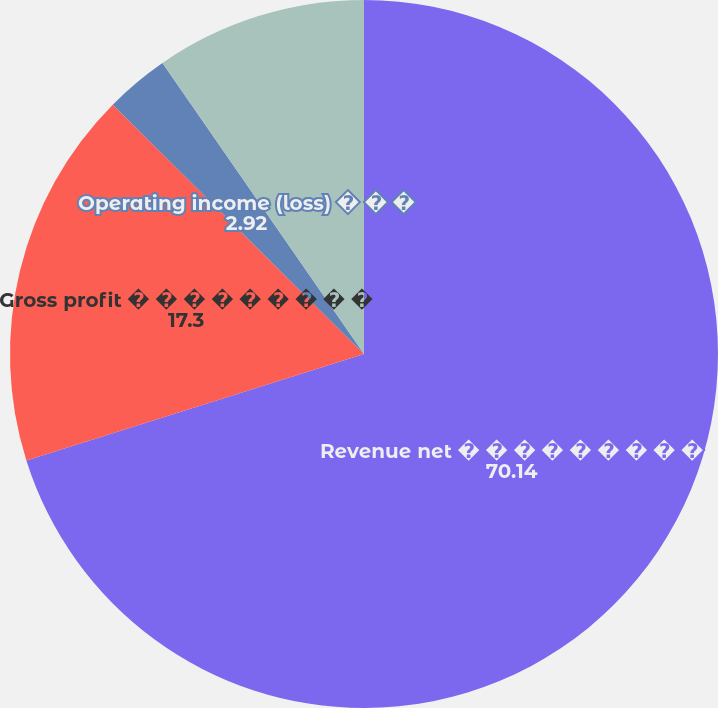Convert chart. <chart><loc_0><loc_0><loc_500><loc_500><pie_chart><fcel>Revenue net � � � � � � � � �<fcel>Gross profit � � � � � � � � �<fcel>Operating income (loss) � � �<fcel>Net income (loss) � � � � � �<nl><fcel>70.14%<fcel>17.3%<fcel>2.92%<fcel>9.64%<nl></chart> 